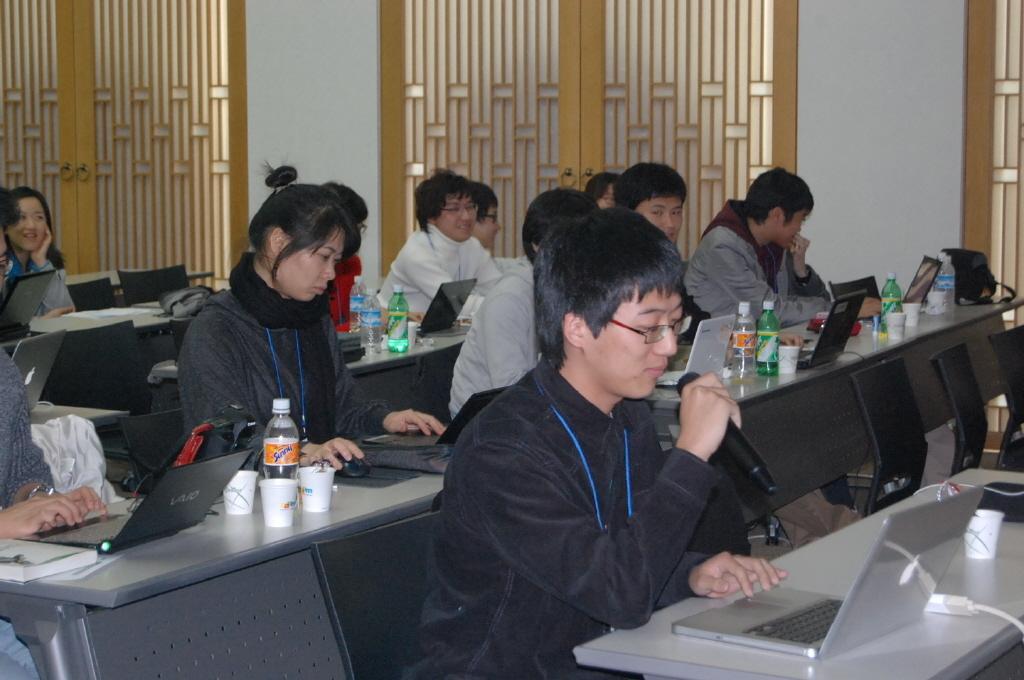Describe this image in one or two sentences. In this picture, we see many people sitting on chair in front of table. On table, we see water bottle, cup, glass, laptops and bag are placed on it and in the middle of the picture, man wearing black shirt is holding microphone in his hands and is talking on it and in front of him, we see laptop and cup which are placed on table and behind him, we see white wall and windows. 